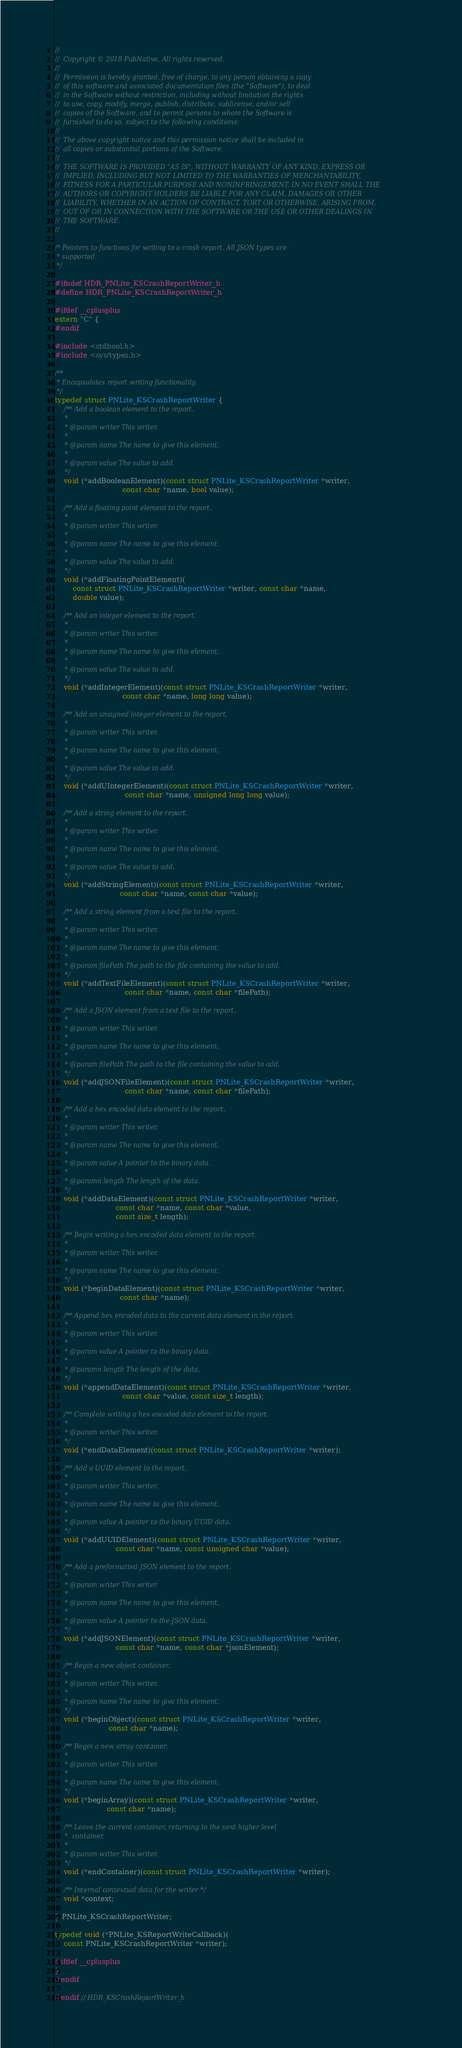<code> <loc_0><loc_0><loc_500><loc_500><_C_>//
//  Copyright © 2018 PubNative. All rights reserved.
//
//  Permission is hereby granted, free of charge, to any person obtaining a copy
//  of this software and associated documentation files (the "Software"), to deal
//  in the Software without restriction, including without limitation the rights
//  to use, copy, modify, merge, publish, distribute, sublicense, and/or sell
//  copies of the Software, and to permit persons to whom the Software is
//  furnished to do so, subject to the following conditions:
//
//  The above copyright notice and this permission notice shall be included in
//  all copies or substantial portions of the Software.
//
//  THE SOFTWARE IS PROVIDED "AS IS", WITHOUT WARRANTY OF ANY KIND, EXPRESS OR
//  IMPLIED, INCLUDING BUT NOT LIMITED TO THE WARRANTIES OF MERCHANTABILITY,
//  FITNESS FOR A PARTICULAR PURPOSE AND NONINFRINGEMENT. IN NO EVENT SHALL THE
//  AUTHORS OR COPYRIGHT HOLDERS BE LIABLE FOR ANY CLAIM, DAMAGES OR OTHER
//  LIABILITY, WHETHER IN AN ACTION OF CONTRACT, TORT OR OTHERWISE, ARISING FROM,
//  OUT OF OR IN CONNECTION WITH THE SOFTWARE OR THE USE OR OTHER DEALINGS IN
//  THE SOFTWARE.
//

/* Pointers to functions for writing to a crash report. All JSON types are
 * supported.
 */

#ifndef HDR_PNLite_KSCrashReportWriter_h
#define HDR_PNLite_KSCrashReportWriter_h

#ifdef __cplusplus
extern "C" {
#endif

#include <stdbool.h>
#include <sys/types.h>

/**
 * Encapsulates report writing functionality.
 */
typedef struct PNLite_KSCrashReportWriter {
    /** Add a boolean element to the report.
     *
     * @param writer This writer.
     *
     * @param name The name to give this element.
     *
     * @param value The value to add.
     */
    void (*addBooleanElement)(const struct PNLite_KSCrashReportWriter *writer,
                              const char *name, bool value);

    /** Add a floating point element to the report.
     *
     * @param writer This writer.
     *
     * @param name The name to give this element.
     *
     * @param value The value to add.
     */
    void (*addFloatingPointElement)(
        const struct PNLite_KSCrashReportWriter *writer, const char *name,
        double value);

    /** Add an integer element to the report.
     *
     * @param writer This writer.
     *
     * @param name The name to give this element.
     *
     * @param value The value to add.
     */
    void (*addIntegerElement)(const struct PNLite_KSCrashReportWriter *writer,
                              const char *name, long long value);

    /** Add an unsigned integer element to the report.
     *
     * @param writer This writer.
     *
     * @param name The name to give this element.
     *
     * @param value The value to add.
     */
    void (*addUIntegerElement)(const struct PNLite_KSCrashReportWriter *writer,
                               const char *name, unsigned long long value);

    /** Add a string element to the report.
     *
     * @param writer This writer.
     *
     * @param name The name to give this element.
     *
     * @param value The value to add.
     */
    void (*addStringElement)(const struct PNLite_KSCrashReportWriter *writer,
                             const char *name, const char *value);

    /** Add a string element from a text file to the report.
     *
     * @param writer This writer.
     *
     * @param name The name to give this element.
     *
     * @param filePath The path to the file containing the value to add.
     */
    void (*addTextFileElement)(const struct PNLite_KSCrashReportWriter *writer,
                               const char *name, const char *filePath);

    /** Add a JSON element from a text file to the report.
     *
     * @param writer This writer.
     *
     * @param name The name to give this element.
     *
     * @param filePath The path to the file containing the value to add.
     */
    void (*addJSONFileElement)(const struct PNLite_KSCrashReportWriter *writer,
                               const char *name, const char *filePath);

    /** Add a hex encoded data element to the report.
     *
     * @param writer This writer.
     *
     * @param name The name to give this element.
     *
     * @param value A pointer to the binary data.
     *
     * @paramn length The length of the data.
     */
    void (*addDataElement)(const struct PNLite_KSCrashReportWriter *writer,
                           const char *name, const char *value,
                           const size_t length);

    /** Begin writing a hex encoded data element to the report.
     *
     * @param writer This writer.
     *
     * @param name The name to give this element.
     */
    void (*beginDataElement)(const struct PNLite_KSCrashReportWriter *writer,
                             const char *name);

    /** Append hex encoded data to the current data element in the report.
     *
     * @param writer This writer.
     *
     * @param value A pointer to the binary data.
     *
     * @paramn length The length of the data.
     */
    void (*appendDataElement)(const struct PNLite_KSCrashReportWriter *writer,
                              const char *value, const size_t length);

    /** Complete writing a hex encoded data element to the report.
     *
     * @param writer This writer.
     */
    void (*endDataElement)(const struct PNLite_KSCrashReportWriter *writer);

    /** Add a UUID element to the report.
     *
     * @param writer This writer.
     *
     * @param name The name to give this element.
     *
     * @param value A pointer to the binary UUID data.
     */
    void (*addUUIDElement)(const struct PNLite_KSCrashReportWriter *writer,
                           const char *name, const unsigned char *value);

    /** Add a preformatted JSON element to the report.
     *
     * @param writer This writer.
     *
     * @param name The name to give this element.
     *
     * @param value A pointer to the JSON data.
     */
    void (*addJSONElement)(const struct PNLite_KSCrashReportWriter *writer,
                           const char *name, const char *jsonElement);

    /** Begin a new object container.
     *
     * @param writer This writer.
     *
     * @param name The name to give this element.
     */
    void (*beginObject)(const struct PNLite_KSCrashReportWriter *writer,
                        const char *name);

    /** Begin a new array container.
     *
     * @param writer This writer.
     *
     * @param name The name to give this element.
     */
    void (*beginArray)(const struct PNLite_KSCrashReportWriter *writer,
                       const char *name);

    /** Leave the current container, returning to the next higher level
     *  container.
     *
     * @param writer This writer.
     */
    void (*endContainer)(const struct PNLite_KSCrashReportWriter *writer);

    /** Internal contextual data for the writer */
    void *context;

} PNLite_KSCrashReportWriter;

typedef void (*PNLite_KSReportWriteCallback)(
    const PNLite_KSCrashReportWriter *writer);

#ifdef __cplusplus
}
#endif

#endif // HDR_KSCrashReportWriter_h
</code> 